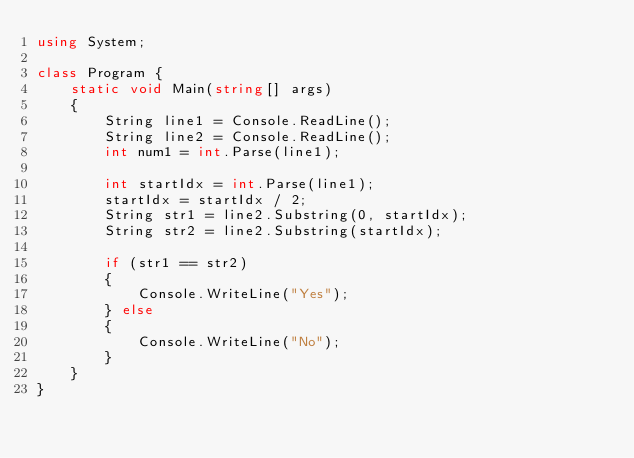Convert code to text. <code><loc_0><loc_0><loc_500><loc_500><_C#_>using System;

class Program {
    static void Main(string[] args)
    {
        String line1 = Console.ReadLine();
        String line2 = Console.ReadLine();
        int num1 = int.Parse(line1);

        int startIdx = int.Parse(line1);
        startIdx = startIdx / 2;
        String str1 = line2.Substring(0, startIdx);
        String str2 = line2.Substring(startIdx);

        if (str1 == str2)
        {
            Console.WriteLine("Yes");
        } else
        {
            Console.WriteLine("No");
        }
    }
}</code> 